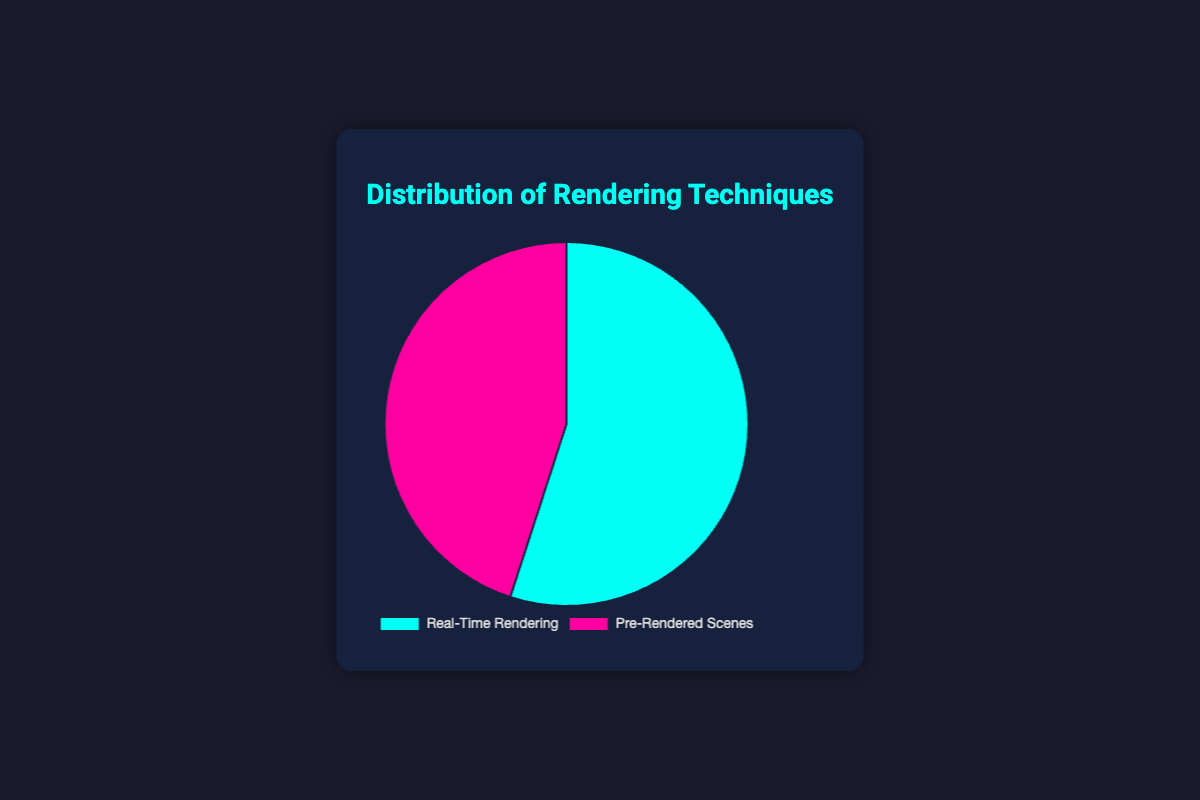What percentage of usage is dedicated to real-time rendering? The figure shows that real-time rendering has a usage percentage of 55%. Thus, the percentage of usage dedicated to real-time rendering is 55%.
Answer: 55% Which rendering technique has a higher usage percentage? By comparing the usage percentages shown in the figure, real-time rendering has a higher usage percentage (55%) compared to pre-rendered scenes (45%).
Answer: Real-time rendering How much greater is the usage percentage of real-time rendering compared to pre-rendered scenes? To find how much greater real-time rendering's usage percentage is, subtract the usage percentage of pre-rendered scenes (45%) from the usage percentage of real-time rendering (55%). The result is 55% - 45% = 10%.
Answer: 10% What is the total percentage represented by both rendering techniques? The total percentage is the sum of the usage percentages of real-time rendering (55%) and pre-rendered scenes (45%). So, 55% + 45% = 100%.
Answer: 100% Which rendering technique is associated with the color blue in the pie chart? The visual attributes in the figure indicate that real-time rendering is associated with the color blue. This can be identified by the blue section of the pie chart.
Answer: Real-time rendering 